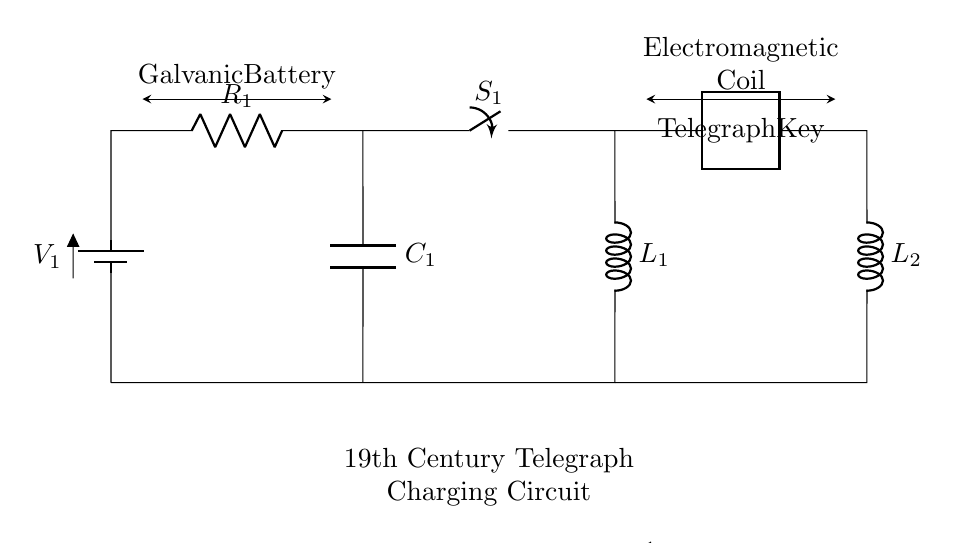What is the voltage source in this circuit? The voltage source is indicated by the battery symbol labeled as V1, which provides the potential difference needed for the circuit operation.
Answer: V1 What type of switch is shown in the circuit? The circuit includes a switch labeled S1, which can open or close the circuit allowing or stopping the current flow through the components.
Answer: S1 What is the purpose of the capacitor in this circuit? The capacitor, labeled C1, stores electrical energy temporarily and can influence the charging behavior of the circuit by smoothing out voltage fluctuations.
Answer: To store energy How many inductors are present in the circuit? There are two inductors in this circuit, labeled as L1 and L2, which are essential for generating magnetic fields and contributing to inductive reactance in the circuit.
Answer: Two What does the telegraph key represent in the circuit? The telegraph key acts as a switch for the telegraph circuit, allowing the operator to control the flow of current and send signals by opening or closing the circuit.
Answer: A switch What happens to current flow when switch S1 is open? When switch S1 is open, the circuit is incomplete, preventing current from flowing through the components and effectively stopping the operation of the entire circuit.
Answer: Current stops What is the primary function of the galvanic battery in this circuit? The galvanic battery serves as the primary power source for the entire circuit, providing the necessary electrical energy to drive the current through the telegraph system and other components.
Answer: Power source 